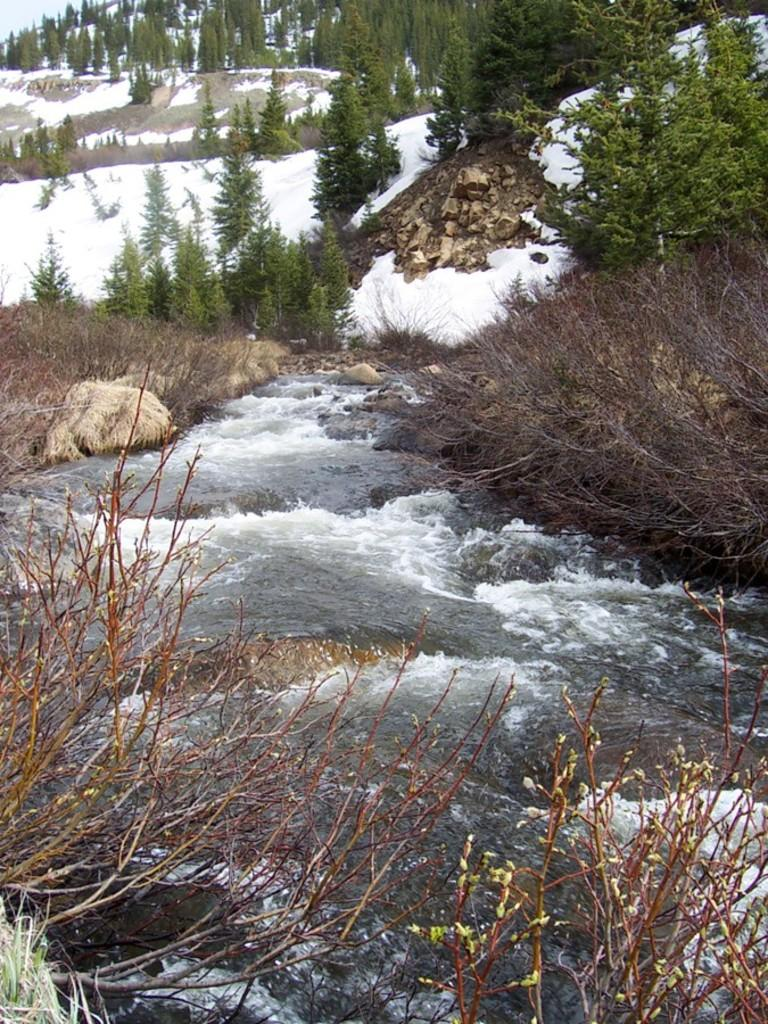What is the primary element present in the image? There is water in the image. What other natural elements can be seen in the image? There are plants, trees, and snow visible in the image. What is visible at the top of the image? The sky is visible at the top of the image. How many hens are jumping on the branch in the image? There are no hens or branches present in the image. 